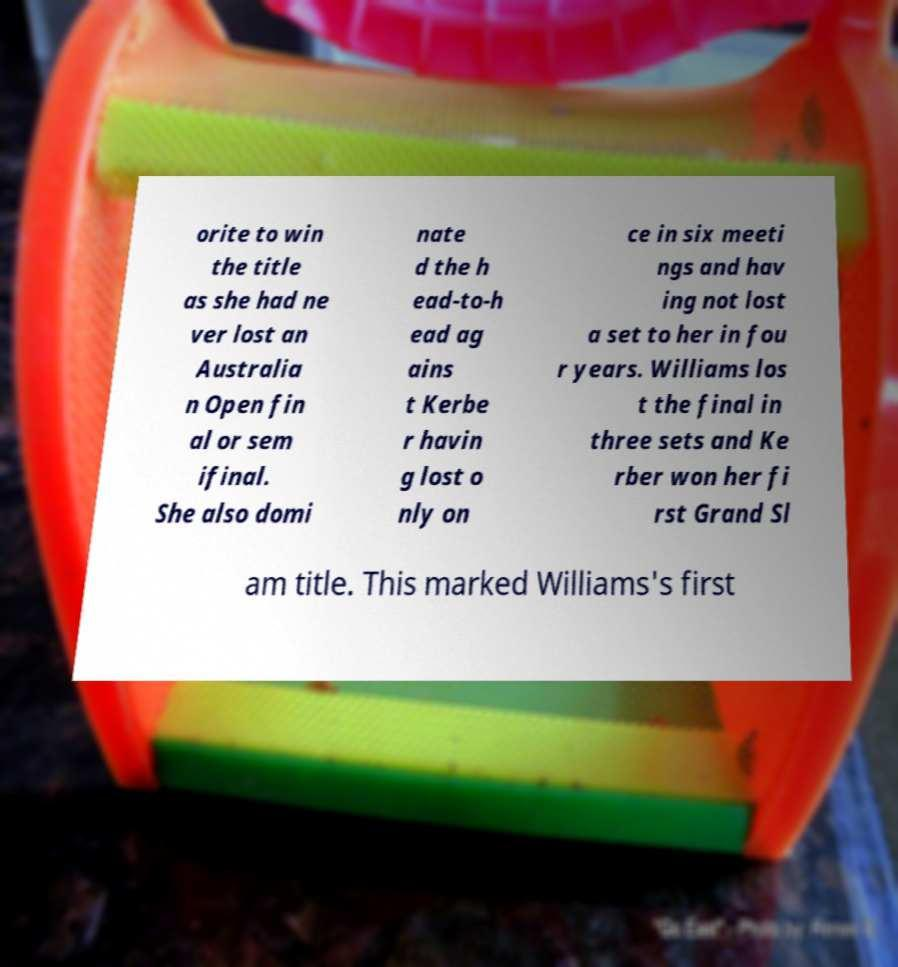I need the written content from this picture converted into text. Can you do that? orite to win the title as she had ne ver lost an Australia n Open fin al or sem ifinal. She also domi nate d the h ead-to-h ead ag ains t Kerbe r havin g lost o nly on ce in six meeti ngs and hav ing not lost a set to her in fou r years. Williams los t the final in three sets and Ke rber won her fi rst Grand Sl am title. This marked Williams's first 